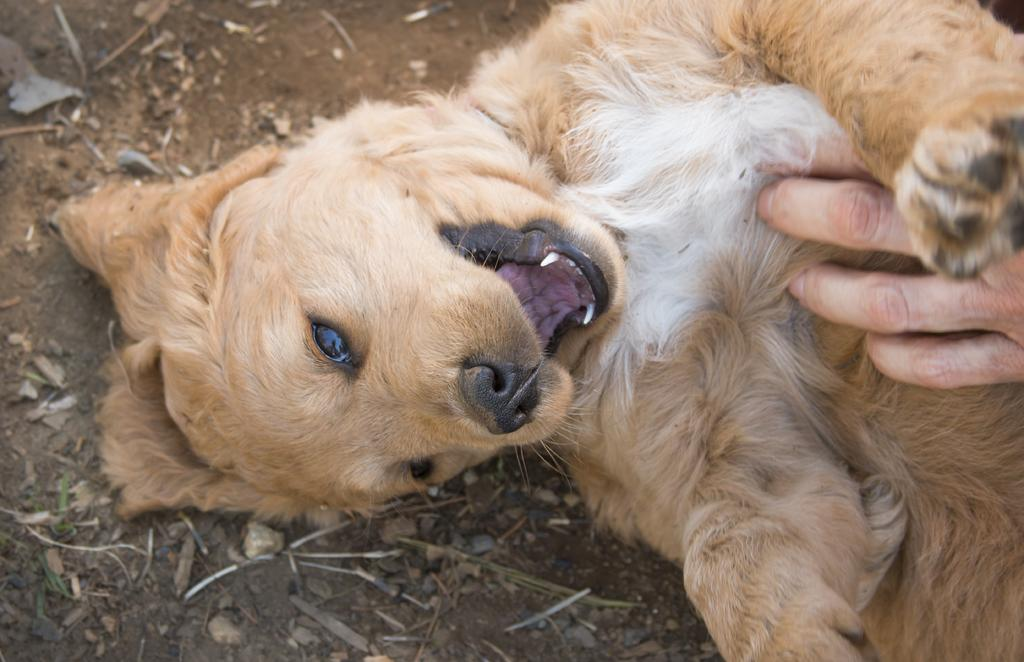What type of animal is present in the image? There is a dog in the image. Can you describe the appearance of the dog? The dog is light brown and white in color. What else can be seen in the image besides the dog? There is a human hand and sand visible in the image. What type of leaf is being held by the dog in the image? There is no leaf present in the image; the dog is not holding anything. 